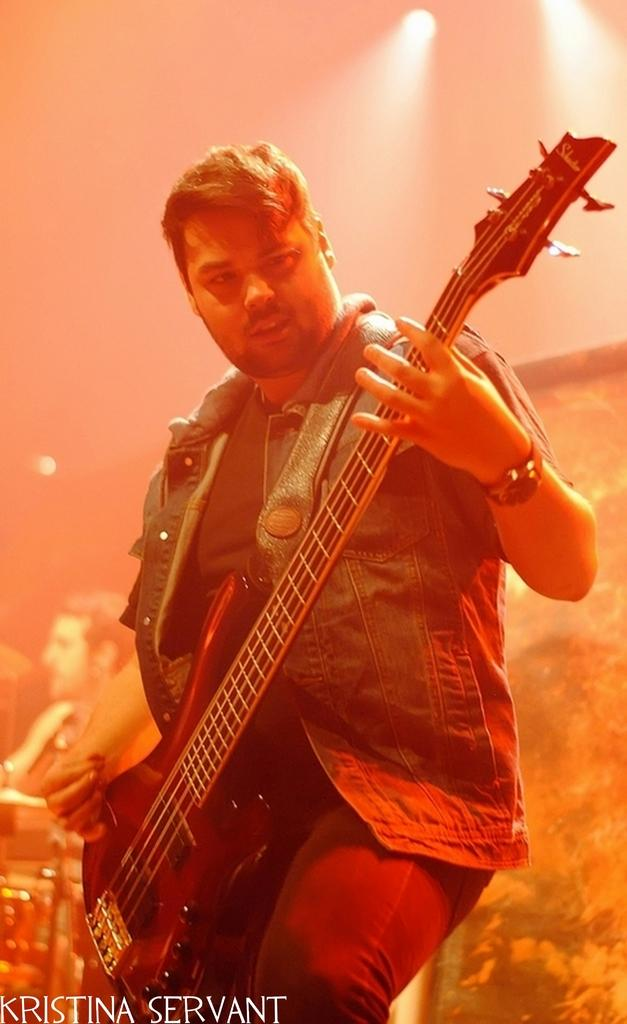What is the main subject of the image? There is a person in the image. What is the person wearing? The person is wearing clothes and a watch. What activity is the person engaged in? The person is playing a guitar. Are there any other people in the image? Yes, there is another person in the bottom left of the image. What type of drain can be seen in the image? There is no drain present in the image. What kind of oil is being used by the person playing the guitar? The image does not show any oil being used, as the person is playing a guitar. 